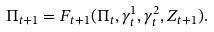Convert formula to latex. <formula><loc_0><loc_0><loc_500><loc_500>\Pi _ { t + 1 } = F _ { t + 1 } ( \Pi _ { t } , \gamma ^ { 1 } _ { t } , \gamma ^ { 2 } _ { t } , Z _ { t + 1 } ) .</formula> 